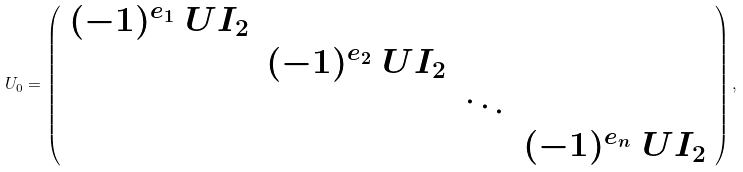<formula> <loc_0><loc_0><loc_500><loc_500>U _ { 0 } = \left ( \begin{array} { c c c c } ( - 1 ) ^ { e _ { 1 } } \ U I _ { 2 } & & & \\ & ( - 1 ) ^ { e _ { 2 } } \ U I _ { 2 } & & \\ & & \ddots & \\ & & & ( - 1 ) ^ { e _ { n } } \ U I _ { 2 } \\ \end{array} \right ) ,</formula> 